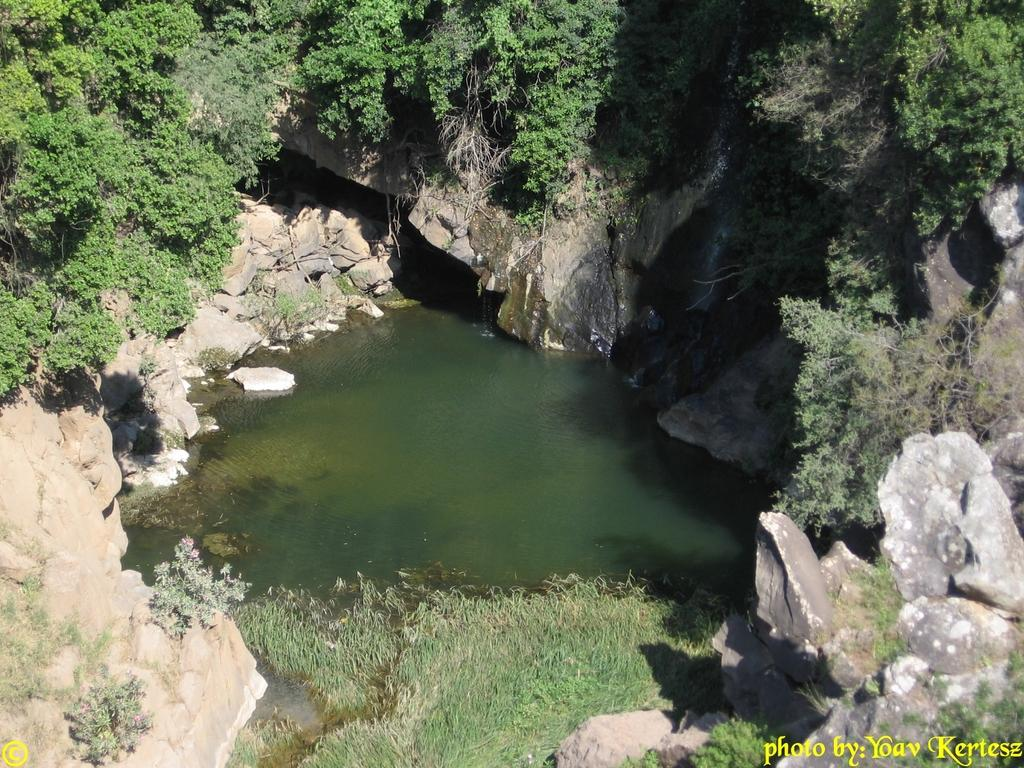What body of water is visible in the image? There is a pond in the image. What surrounds the pond? Hills surround the pond. What can be found on the hills? Trees are present on the hills. Where can text be found in the image? There is text in the bottom right and bottom left of the image. Can you see the moon in the image? The moon is not present in the image; it features a pond, hills, trees, and text. 